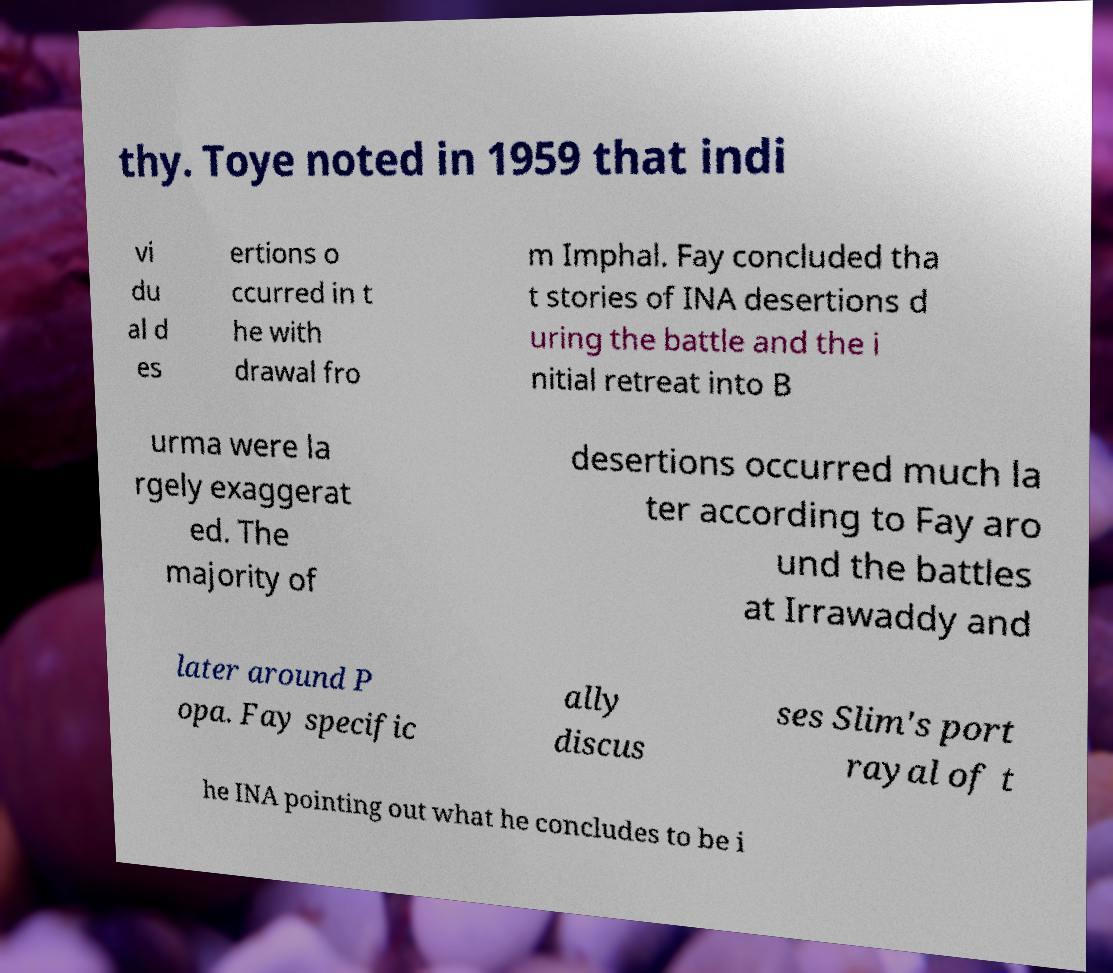Could you extract and type out the text from this image? thy. Toye noted in 1959 that indi vi du al d es ertions o ccurred in t he with drawal fro m Imphal. Fay concluded tha t stories of INA desertions d uring the battle and the i nitial retreat into B urma were la rgely exaggerat ed. The majority of desertions occurred much la ter according to Fay aro und the battles at Irrawaddy and later around P opa. Fay specific ally discus ses Slim's port rayal of t he INA pointing out what he concludes to be i 